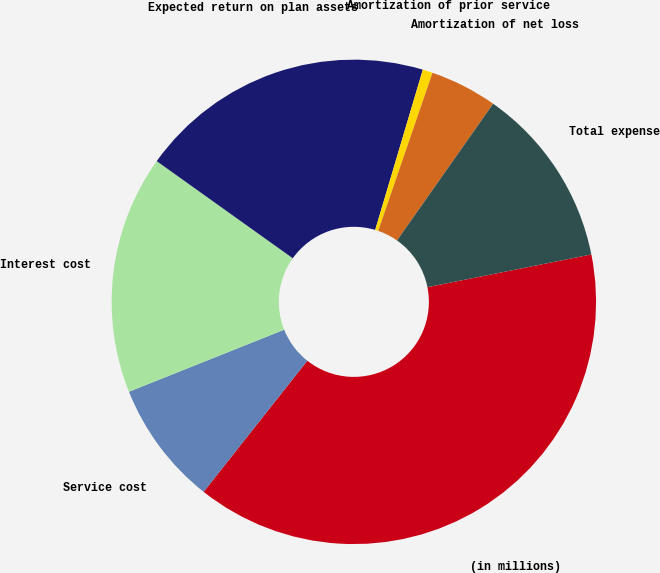Convert chart to OTSL. <chart><loc_0><loc_0><loc_500><loc_500><pie_chart><fcel>(in millions)<fcel>Service cost<fcel>Interest cost<fcel>Expected return on plan assets<fcel>Amortization of prior service<fcel>Amortization of net loss<fcel>Total expense<nl><fcel>38.79%<fcel>8.3%<fcel>15.92%<fcel>19.73%<fcel>0.67%<fcel>4.49%<fcel>12.11%<nl></chart> 